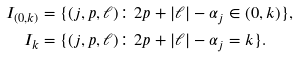<formula> <loc_0><loc_0><loc_500><loc_500>I _ { ( 0 , k ) } & = \{ ( j , p , \ell ) \colon 2 p + | \ell | - \alpha _ { j } \in ( 0 , k ) \} , \\ I _ { k } & = \{ ( j , p , \ell ) \colon 2 p + | \ell | - \alpha _ { j } = k \} . \\</formula> 